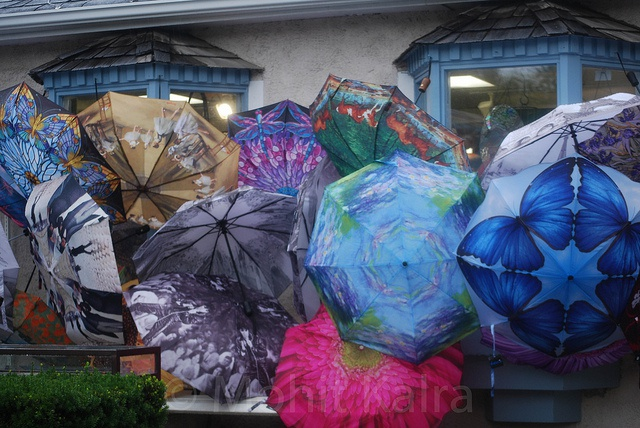Describe the objects in this image and their specific colors. I can see umbrella in darkgray, navy, black, blue, and darkblue tones, umbrella in darkgray, gray, teal, and lightblue tones, umbrella in darkgray, purple, and black tones, umbrella in darkgray, purple, maroon, and brown tones, and umbrella in darkgray, gray, black, and navy tones in this image. 